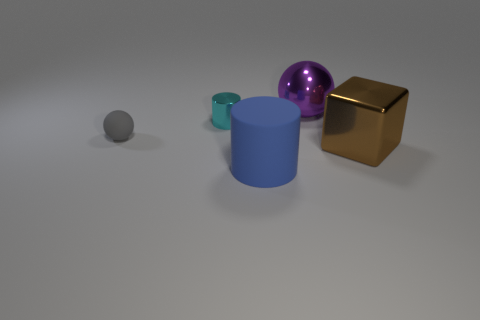Add 2 small gray things. How many objects exist? 7 Subtract all cylinders. How many objects are left? 3 Subtract 1 cylinders. How many cylinders are left? 1 Add 1 brown metallic cubes. How many brown metallic cubes are left? 2 Add 4 purple objects. How many purple objects exist? 5 Subtract 1 gray balls. How many objects are left? 4 Subtract all purple balls. Subtract all green cylinders. How many balls are left? 1 Subtract all brown spheres. How many yellow cubes are left? 0 Subtract all big metal objects. Subtract all small gray balls. How many objects are left? 2 